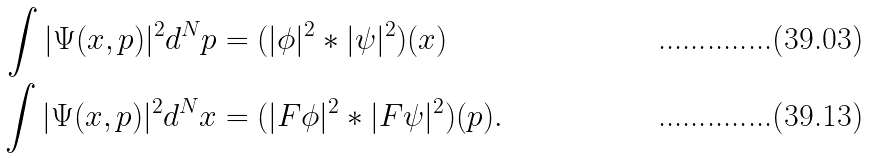Convert formula to latex. <formula><loc_0><loc_0><loc_500><loc_500>\int | \Psi ( x , p ) | ^ { 2 } d ^ { N } p & = ( | \phi | ^ { 2 } \ast | \psi | ^ { 2 } ) ( x ) \\ \int | \Psi ( x , p ) | ^ { 2 } d ^ { N } x & = ( | F \phi | ^ { 2 } \ast | F \psi | ^ { 2 } ) ( p ) .</formula> 